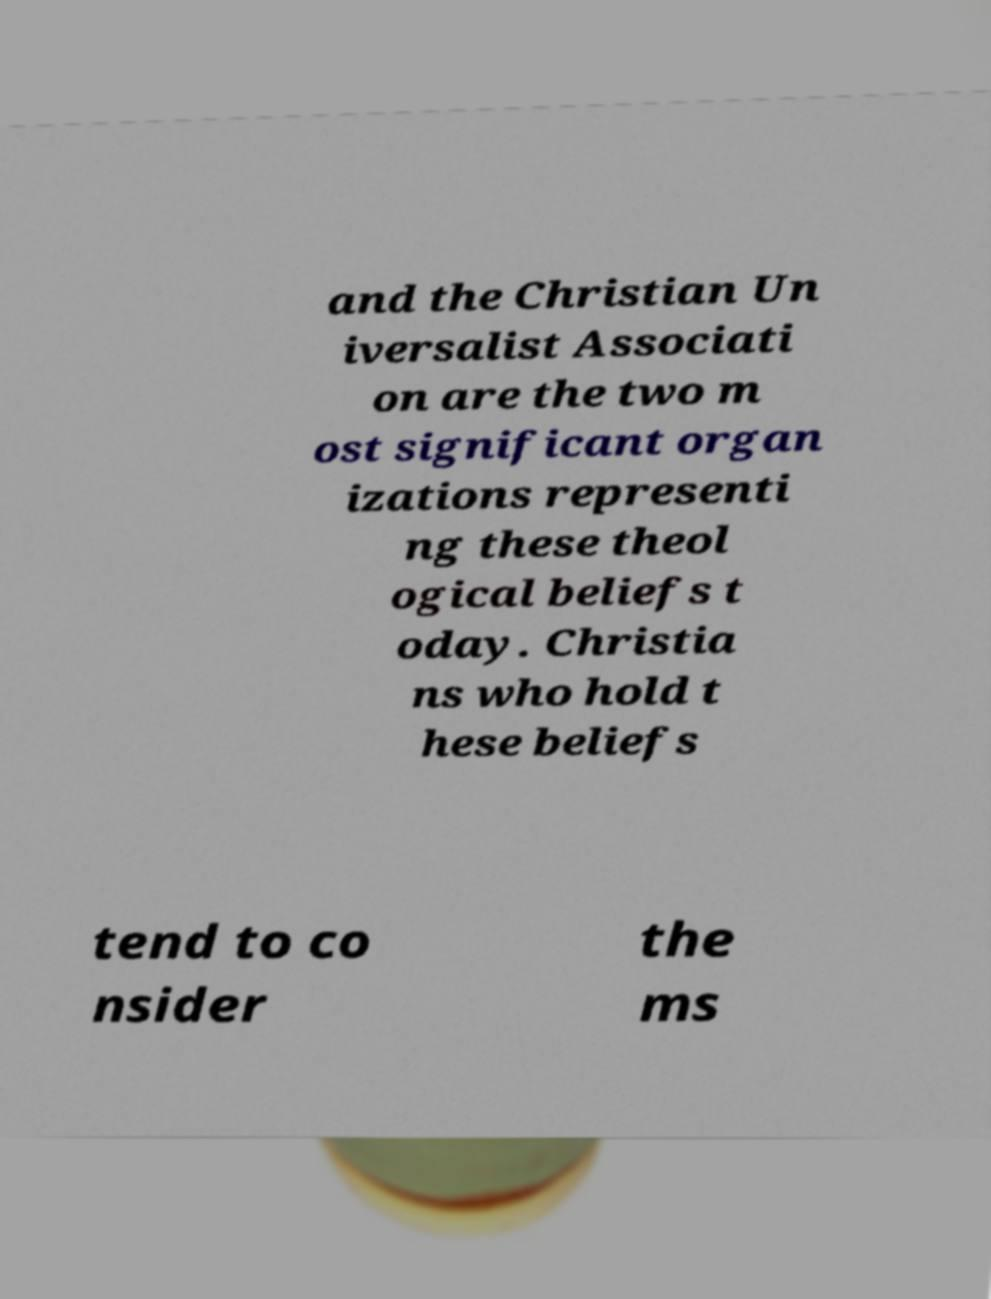What messages or text are displayed in this image? I need them in a readable, typed format. and the Christian Un iversalist Associati on are the two m ost significant organ izations representi ng these theol ogical beliefs t oday. Christia ns who hold t hese beliefs tend to co nsider the ms 